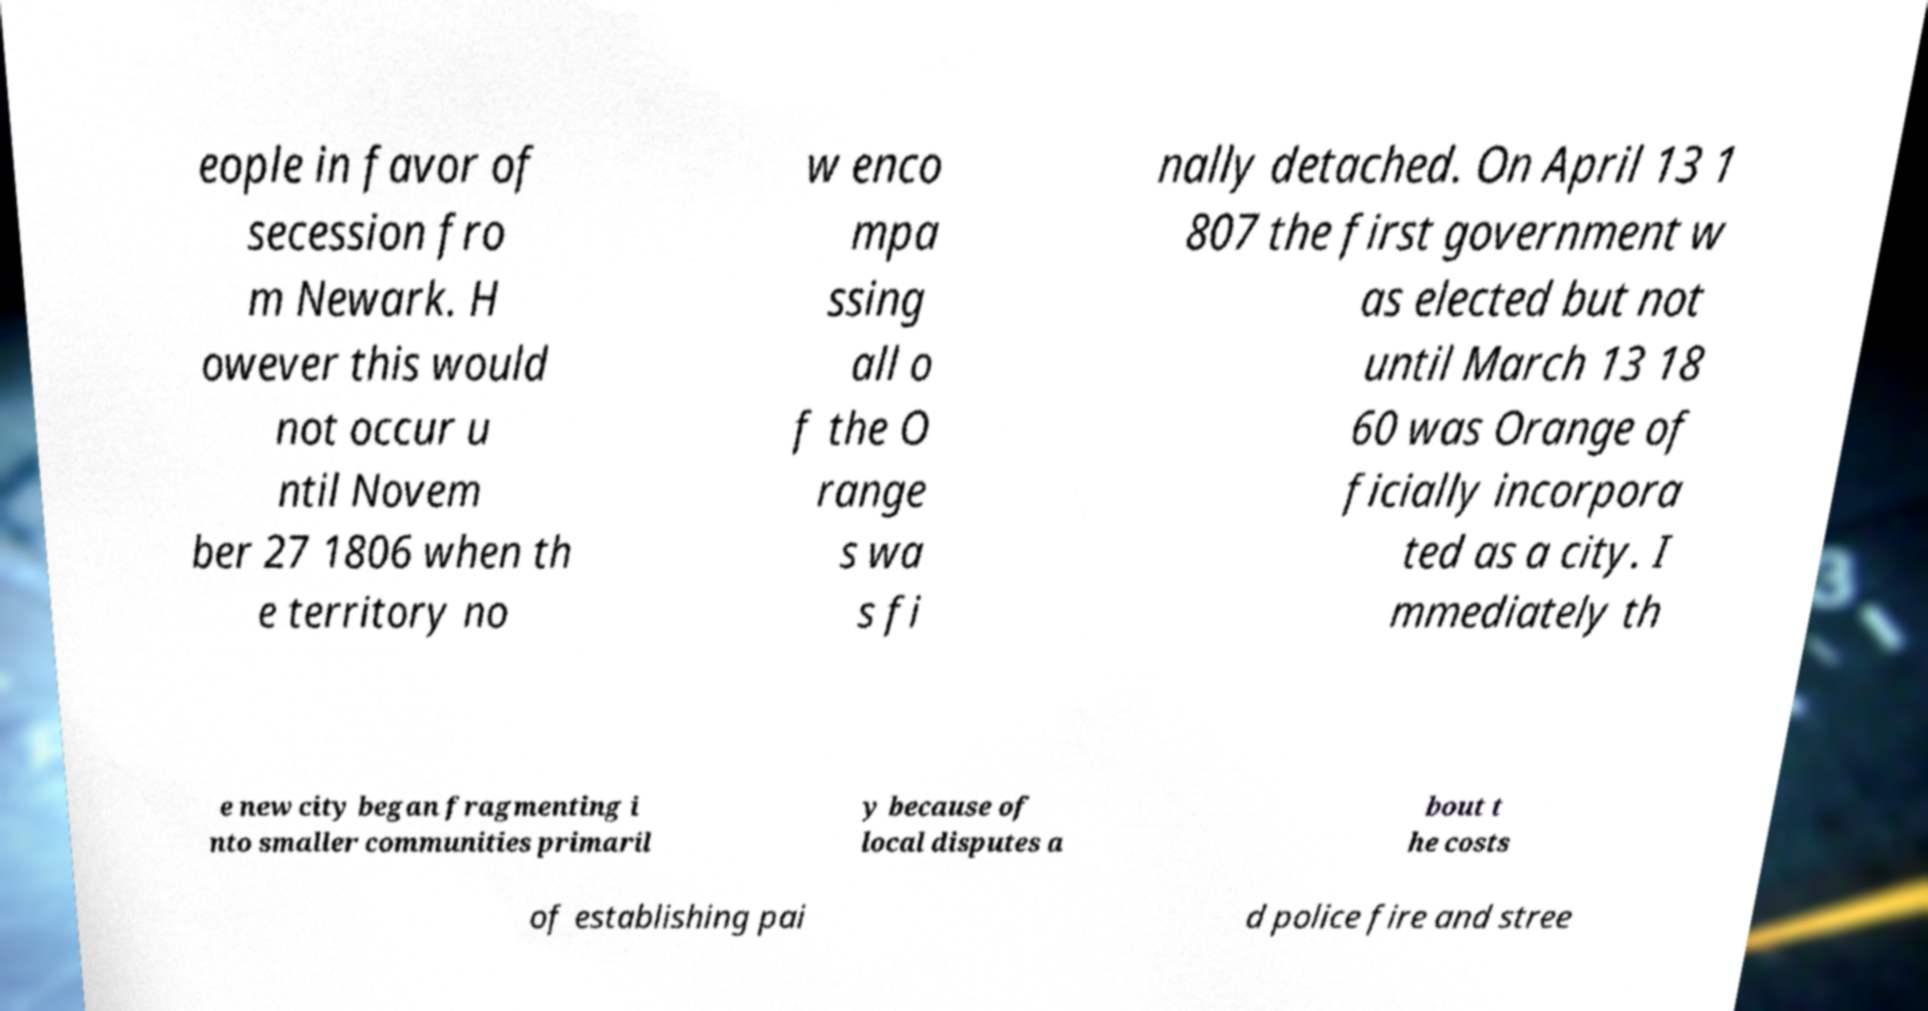Please read and relay the text visible in this image. What does it say? eople in favor of secession fro m Newark. H owever this would not occur u ntil Novem ber 27 1806 when th e territory no w enco mpa ssing all o f the O range s wa s fi nally detached. On April 13 1 807 the first government w as elected but not until March 13 18 60 was Orange of ficially incorpora ted as a city. I mmediately th e new city began fragmenting i nto smaller communities primaril y because of local disputes a bout t he costs of establishing pai d police fire and stree 